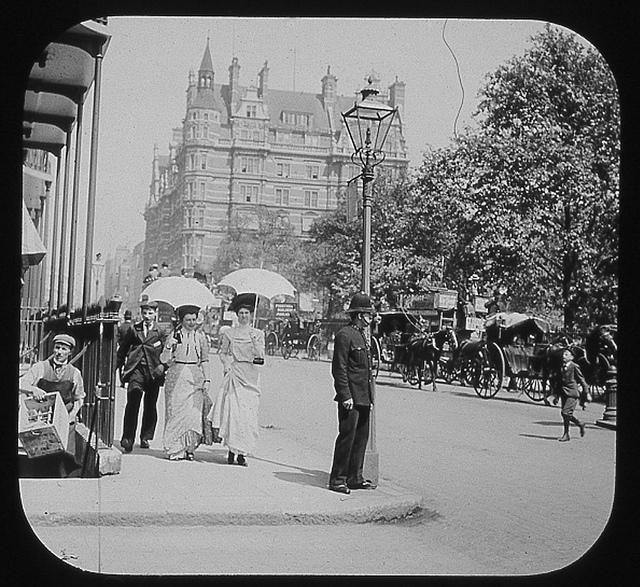What are the women on the left holding?
Select the correct answer and articulate reasoning with the following format: 'Answer: answer
Rationale: rationale.'
Options: Babies, eggs, cats, umbrellas. Answer: umbrellas.
Rationale: These are held over the head for environment protection. 